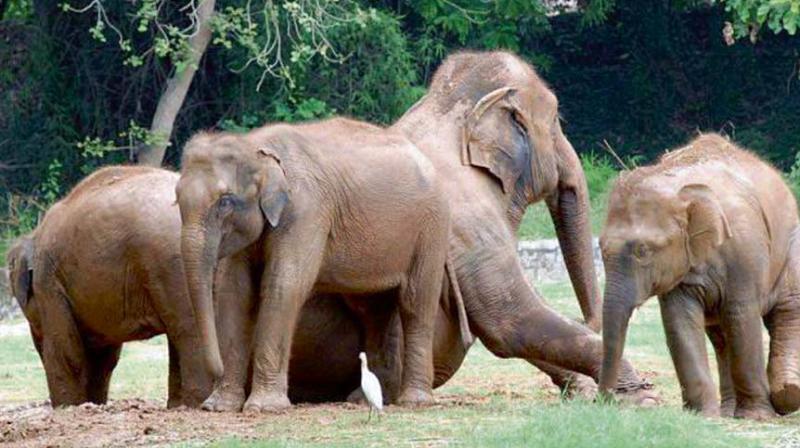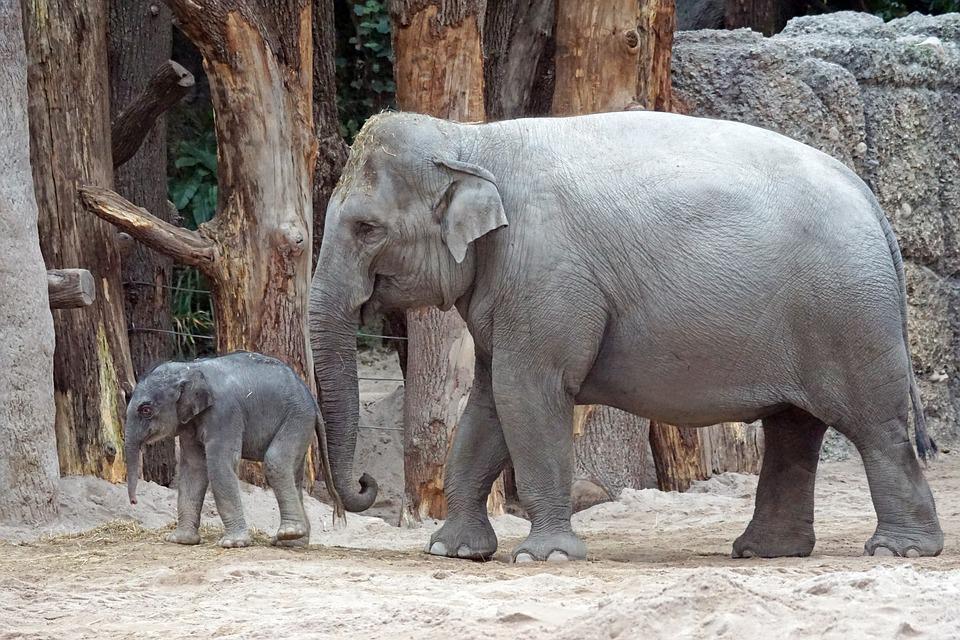The first image is the image on the left, the second image is the image on the right. Evaluate the accuracy of this statement regarding the images: "The animals in one of the images have horns.". Is it true? Answer yes or no. No. 